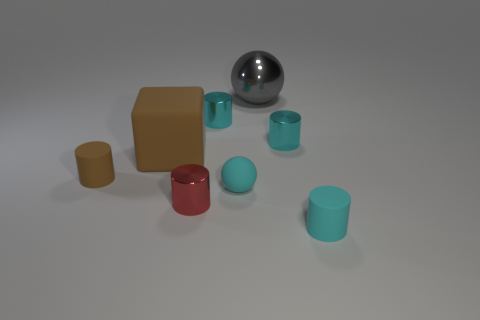Do the big brown cube and the small cyan sphere have the same material?
Give a very brief answer. Yes. How many other objects are the same material as the cyan ball?
Provide a short and direct response. 3. How many small objects are to the left of the large gray metallic object and right of the brown rubber cylinder?
Provide a succinct answer. 3. The block has what color?
Give a very brief answer. Brown. There is another object that is the same shape as the big gray object; what material is it?
Ensure brevity in your answer.  Rubber. Is there anything else that is the same material as the red cylinder?
Keep it short and to the point. Yes. Is the matte ball the same color as the rubber block?
Give a very brief answer. No. There is a cyan matte object that is left of the tiny cyan thing in front of the cyan rubber ball; what is its shape?
Provide a succinct answer. Sphere. The red object that is the same material as the gray ball is what shape?
Give a very brief answer. Cylinder. How many other things are there of the same shape as the small red shiny thing?
Make the answer very short. 4. 